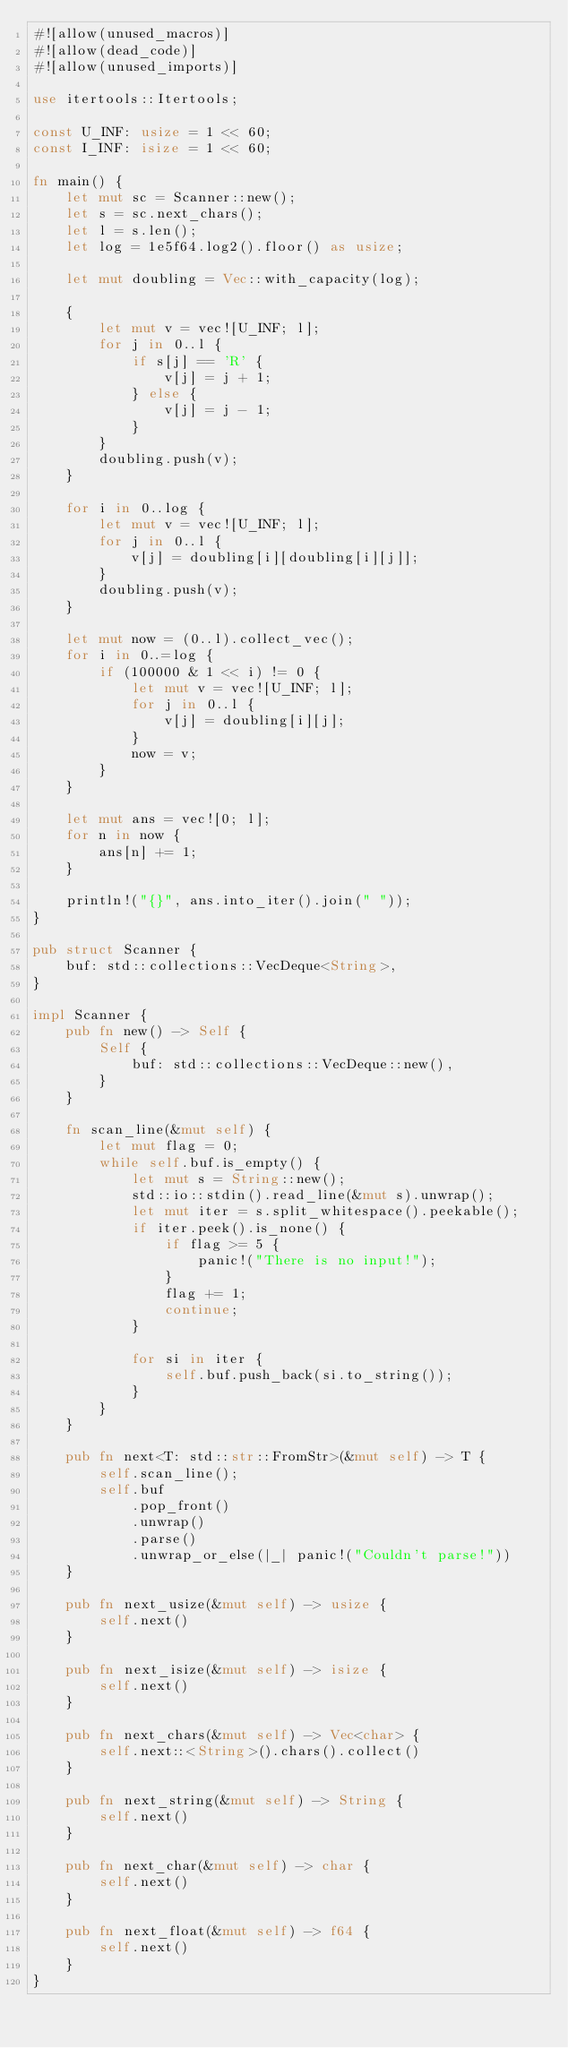<code> <loc_0><loc_0><loc_500><loc_500><_Rust_>#![allow(unused_macros)]
#![allow(dead_code)]
#![allow(unused_imports)]

use itertools::Itertools;

const U_INF: usize = 1 << 60;
const I_INF: isize = 1 << 60;

fn main() {
    let mut sc = Scanner::new();
    let s = sc.next_chars();
    let l = s.len();
    let log = 1e5f64.log2().floor() as usize;

    let mut doubling = Vec::with_capacity(log);

    {
        let mut v = vec![U_INF; l];
        for j in 0..l {
            if s[j] == 'R' {
                v[j] = j + 1;
            } else {
                v[j] = j - 1;
            }
        }
        doubling.push(v);
    }

    for i in 0..log {
        let mut v = vec![U_INF; l];
        for j in 0..l {
            v[j] = doubling[i][doubling[i][j]];
        }
        doubling.push(v);
    }

    let mut now = (0..l).collect_vec();
    for i in 0..=log {
        if (100000 & 1 << i) != 0 {
            let mut v = vec![U_INF; l];
            for j in 0..l {
                v[j] = doubling[i][j];
            }
            now = v;
        }
    }

    let mut ans = vec![0; l];
    for n in now {
        ans[n] += 1;
    }

    println!("{}", ans.into_iter().join(" "));
}

pub struct Scanner {
    buf: std::collections::VecDeque<String>,
}

impl Scanner {
    pub fn new() -> Self {
        Self {
            buf: std::collections::VecDeque::new(),
        }
    }

    fn scan_line(&mut self) {
        let mut flag = 0;
        while self.buf.is_empty() {
            let mut s = String::new();
            std::io::stdin().read_line(&mut s).unwrap();
            let mut iter = s.split_whitespace().peekable();
            if iter.peek().is_none() {
                if flag >= 5 {
                    panic!("There is no input!");
                }
                flag += 1;
                continue;
            }

            for si in iter {
                self.buf.push_back(si.to_string());
            }
        }
    }

    pub fn next<T: std::str::FromStr>(&mut self) -> T {
        self.scan_line();
        self.buf
            .pop_front()
            .unwrap()
            .parse()
            .unwrap_or_else(|_| panic!("Couldn't parse!"))
    }

    pub fn next_usize(&mut self) -> usize {
        self.next()
    }

    pub fn next_isize(&mut self) -> isize {
        self.next()
    }

    pub fn next_chars(&mut self) -> Vec<char> {
        self.next::<String>().chars().collect()
    }

    pub fn next_string(&mut self) -> String {
        self.next()
    }

    pub fn next_char(&mut self) -> char {
        self.next()
    }

    pub fn next_float(&mut self) -> f64 {
        self.next()
    }
}
</code> 